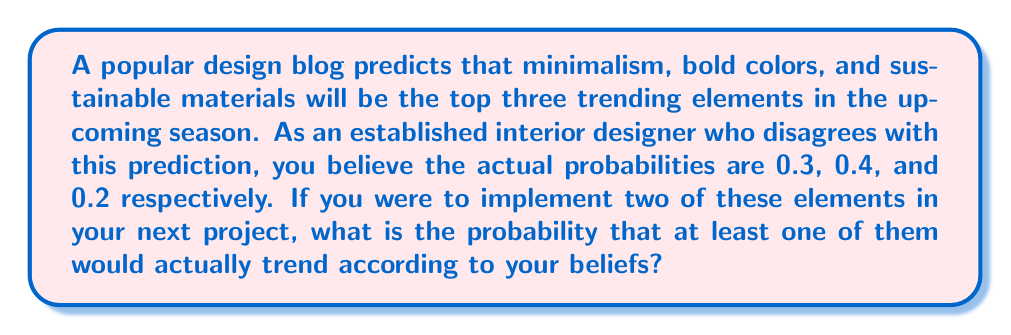Teach me how to tackle this problem. Let's approach this step-by-step:

1) First, we need to calculate the probability of selecting two elements out of the three. There are three possible combinations:
   - Minimalism and Bold colors
   - Minimalism and Sustainable materials
   - Bold colors and Sustainable materials

2) Now, let's calculate the probability that at least one of the chosen elements trends:

   For each combination:
   P(at least one trends) = 1 - P(neither trends)

3) For Minimalism and Bold colors:
   P(at least one trends) = 1 - (1 - 0.3)(1 - 0.4) = 1 - 0.42 = 0.58

4) For Minimalism and Sustainable materials:
   P(at least one trends) = 1 - (1 - 0.3)(1 - 0.2) = 1 - 0.56 = 0.44

5) For Bold colors and Sustainable materials:
   P(at least one trends) = 1 - (1 - 0.4)(1 - 0.2) = 1 - 0.48 = 0.52

6) Since each combination is equally likely to be chosen, the overall probability is the average of these three probabilities:

   $$P(\text{at least one trends}) = \frac{0.58 + 0.44 + 0.52}{3} = \frac{1.54}{3} \approx 0.5133$$

Therefore, the probability that at least one of the two chosen elements would actually trend is approximately 0.5133 or 51.33%.
Answer: $\frac{1.54}{3} \approx 0.5133$ or $51.33\%$ 